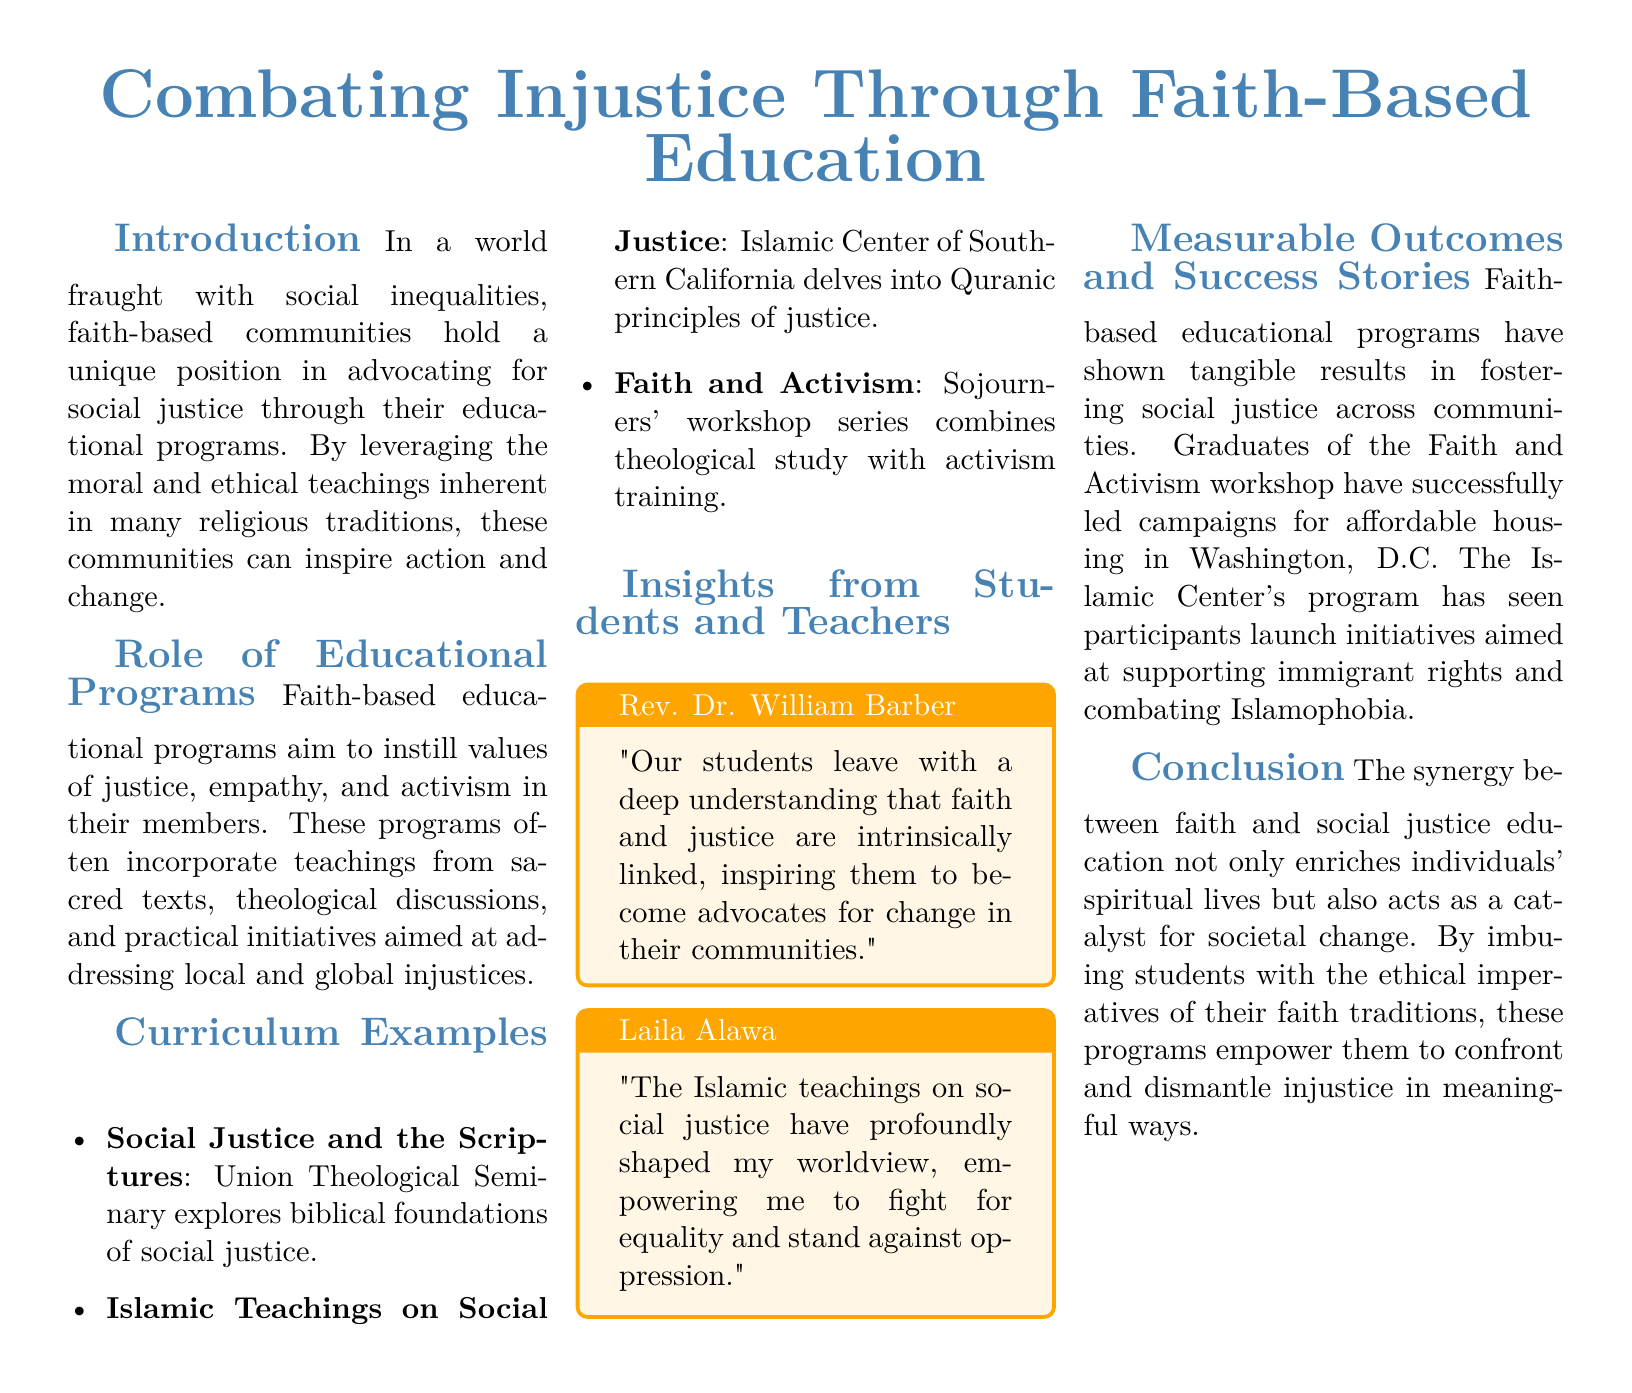what is the title of the document? The title is found at the top of the document, indicating the main topic.
Answer: Combating Injustice Through Faith-Based Education who conducted the workshop series that combines theological study with activism training? The document states the organization that conducts this workshop series.
Answer: Sojourners what is one example of a curriculum discussed in the document? The document lists several curriculum examples related to social justice in faith-based education.
Answer: Social Justice and the Scriptures who is referenced as Rev. Dr. William Barber? This person is highlighted in a quote box providing insights about students' understanding of faith and justice.
Answer: A student and teacher how have graduates of the Faith and Activism workshop contributed to their community? The document explains the impact of the educational program on graduates.
Answer: Led campaigns for affordable housing in which city did participants of the Islamic Center's program launch initiatives? The document specifies the location of successful initiatives launched by program participants.
Answer: Washington, D.C what is the main conclusion of the document? The document summarizes the overall implication of faith-based education in relation to social justice.
Answer: Catalyst for societal change what colors are primarily used in the document? The document describes the main and secondary colors used in its layout.
Answer: Main color: RGB(70,130,180); Second color: RGB(255,165,0) how many sections are there in the document? The sections of the document can be counted to determine the number.
Answer: Six sections 